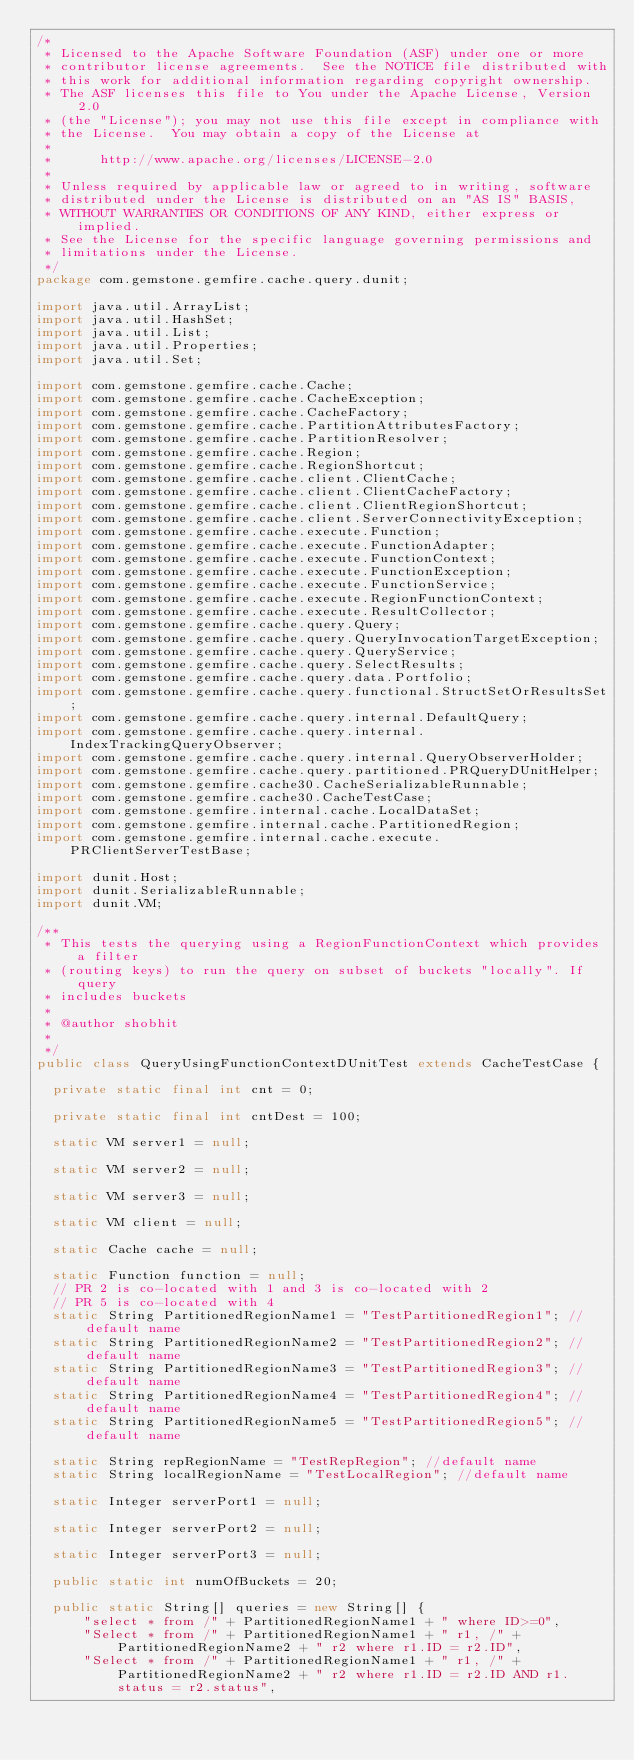Convert code to text. <code><loc_0><loc_0><loc_500><loc_500><_Java_>/*
 * Licensed to the Apache Software Foundation (ASF) under one or more
 * contributor license agreements.  See the NOTICE file distributed with
 * this work for additional information regarding copyright ownership.
 * The ASF licenses this file to You under the Apache License, Version 2.0
 * (the "License"); you may not use this file except in compliance with
 * the License.  You may obtain a copy of the License at
 *
 *      http://www.apache.org/licenses/LICENSE-2.0
 *
 * Unless required by applicable law or agreed to in writing, software
 * distributed under the License is distributed on an "AS IS" BASIS,
 * WITHOUT WARRANTIES OR CONDITIONS OF ANY KIND, either express or implied.
 * See the License for the specific language governing permissions and
 * limitations under the License.
 */
package com.gemstone.gemfire.cache.query.dunit;

import java.util.ArrayList;
import java.util.HashSet;
import java.util.List;
import java.util.Properties;
import java.util.Set;

import com.gemstone.gemfire.cache.Cache;
import com.gemstone.gemfire.cache.CacheException;
import com.gemstone.gemfire.cache.CacheFactory;
import com.gemstone.gemfire.cache.PartitionAttributesFactory;
import com.gemstone.gemfire.cache.PartitionResolver;
import com.gemstone.gemfire.cache.Region;
import com.gemstone.gemfire.cache.RegionShortcut;
import com.gemstone.gemfire.cache.client.ClientCache;
import com.gemstone.gemfire.cache.client.ClientCacheFactory;
import com.gemstone.gemfire.cache.client.ClientRegionShortcut;
import com.gemstone.gemfire.cache.client.ServerConnectivityException;
import com.gemstone.gemfire.cache.execute.Function;
import com.gemstone.gemfire.cache.execute.FunctionAdapter;
import com.gemstone.gemfire.cache.execute.FunctionContext;
import com.gemstone.gemfire.cache.execute.FunctionException;
import com.gemstone.gemfire.cache.execute.FunctionService;
import com.gemstone.gemfire.cache.execute.RegionFunctionContext;
import com.gemstone.gemfire.cache.execute.ResultCollector;
import com.gemstone.gemfire.cache.query.Query;
import com.gemstone.gemfire.cache.query.QueryInvocationTargetException;
import com.gemstone.gemfire.cache.query.QueryService;
import com.gemstone.gemfire.cache.query.SelectResults;
import com.gemstone.gemfire.cache.query.data.Portfolio;
import com.gemstone.gemfire.cache.query.functional.StructSetOrResultsSet;
import com.gemstone.gemfire.cache.query.internal.DefaultQuery;
import com.gemstone.gemfire.cache.query.internal.IndexTrackingQueryObserver;
import com.gemstone.gemfire.cache.query.internal.QueryObserverHolder;
import com.gemstone.gemfire.cache.query.partitioned.PRQueryDUnitHelper;
import com.gemstone.gemfire.cache30.CacheSerializableRunnable;
import com.gemstone.gemfire.cache30.CacheTestCase;
import com.gemstone.gemfire.internal.cache.LocalDataSet;
import com.gemstone.gemfire.internal.cache.PartitionedRegion;
import com.gemstone.gemfire.internal.cache.execute.PRClientServerTestBase;

import dunit.Host;
import dunit.SerializableRunnable;
import dunit.VM;

/**
 * This tests the querying using a RegionFunctionContext which provides a filter
 * (routing keys) to run the query on subset of buckets "locally". If query
 * includes buckets
 *
 * @author shobhit
 *
 */
public class QueryUsingFunctionContextDUnitTest extends CacheTestCase {

  private static final int cnt = 0;

  private static final int cntDest = 100;

  static VM server1 = null;

  static VM server2 = null;

  static VM server3 = null;

  static VM client = null;

  static Cache cache = null;

  static Function function = null;
  // PR 2 is co-located with 1 and 3 is co-located with 2
  // PR 5 is co-located with 4
  static String PartitionedRegionName1 = "TestPartitionedRegion1"; //default name
  static String PartitionedRegionName2 = "TestPartitionedRegion2"; //default name
  static String PartitionedRegionName3 = "TestPartitionedRegion3"; //default name
  static String PartitionedRegionName4 = "TestPartitionedRegion4"; //default name
  static String PartitionedRegionName5 = "TestPartitionedRegion5"; //default name

  static String repRegionName = "TestRepRegion"; //default name
  static String localRegionName = "TestLocalRegion"; //default name

  static Integer serverPort1 = null;

  static Integer serverPort2 = null;

  static Integer serverPort3 = null;

  public static int numOfBuckets = 20;

  public static String[] queries = new String[] {
      "select * from /" + PartitionedRegionName1 + " where ID>=0",
      "Select * from /" + PartitionedRegionName1 + " r1, /" + PartitionedRegionName2 + " r2 where r1.ID = r2.ID",
      "Select * from /" + PartitionedRegionName1 + " r1, /" + PartitionedRegionName2 + " r2 where r1.ID = r2.ID AND r1.status = r2.status",</code> 